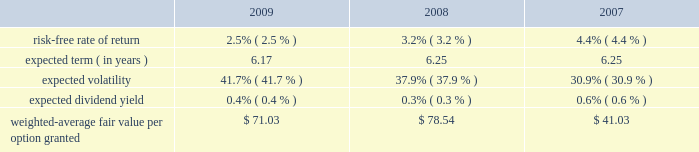Mastercard incorporated notes to consolidated financial statements 2014 ( continued ) ( in thousands , except percent and per share data ) upon termination of employment , excluding retirement , all of a participant 2019s unvested awards are forfeited .
However , when a participant terminates employment due to retirement , the participant generally retains all of their awards without providing additional service to the company .
Eligible retirement is dependent upon age and years of service , as follows : age 55 with ten years of service , age 60 with five years of service and age 65 with two years of service .
Compensation expense is recognized over the shorter of the vesting periods stated in the ltip , or the date the individual becomes eligible to retire .
There are 11550 shares of class a common stock reserved for equity awards under the ltip .
Although the ltip permits the issuance of shares of class b common stock , no such shares have been reserved for issuance .
Shares issued as a result of option exercises and the conversions of rsus are expected to be funded with the issuance of new shares of class a common stock .
Stock options the fair value of each option is estimated on the date of grant using a black-scholes option pricing model .
The table presents the weighted-average assumptions used in the valuation and the resulting weighted- average fair value per option granted for the years ended december 31: .
The risk-free rate of return was based on the u.s .
Treasury yield curve in effect on the date of grant .
The company utilizes the simplified method for calculating the expected term of the option based on the vesting terms and the contractual life of the option .
The expected volatility for options granted during 2009 was based on the average of the implied volatility of mastercard and a blend of the historical volatility of mastercard and the historical volatility of a group of companies that management believes is generally comparable to mastercard .
The expected volatility for options granted during 2008 was based on the average of the implied volatility of mastercard and the historical volatility of a group of companies that management believes is generally comparable to mastercard .
As the company did not have sufficient publicly traded stock data historically , the expected volatility for options granted during 2007 was primarily based on the average of the historical and implied volatility of a group of companies that management believed was generally comparable to mastercard .
The expected dividend yields were based on the company 2019s expected annual dividend rate on the date of grant. .
What was the percent of the increase in the weighted-average fair value per option granted from 2007 to 2008? 
Computations: ((78.54 - 41.03) / 41.03)
Answer: 0.91421. 